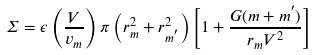Convert formula to latex. <formula><loc_0><loc_0><loc_500><loc_500>\Sigma = \epsilon \left ( \frac { V } { v _ { m } } \right ) \pi \left ( r _ { m } ^ { 2 } + r _ { m ^ { ^ { \prime } } } ^ { 2 } \right ) \left [ 1 + \frac { G ( m + m ^ { ^ { \prime } } ) } { r _ { m } V ^ { 2 } } \right ]</formula> 